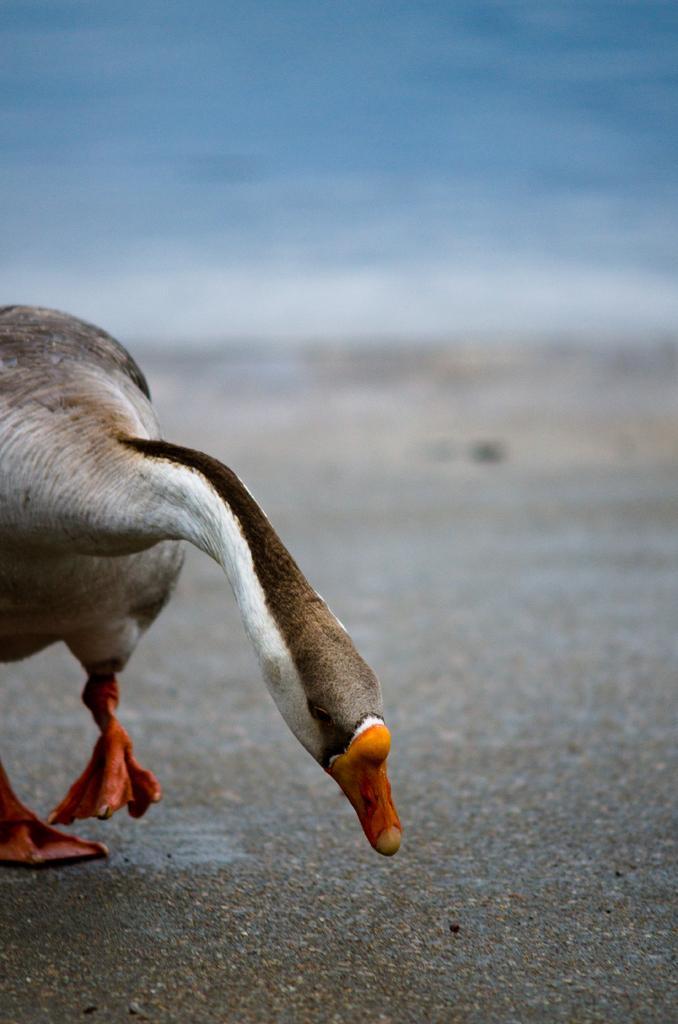Can you describe this image briefly? In this picture we can observe a duck which is in white and brown color. The duck is on the sand. In the background there is water. 